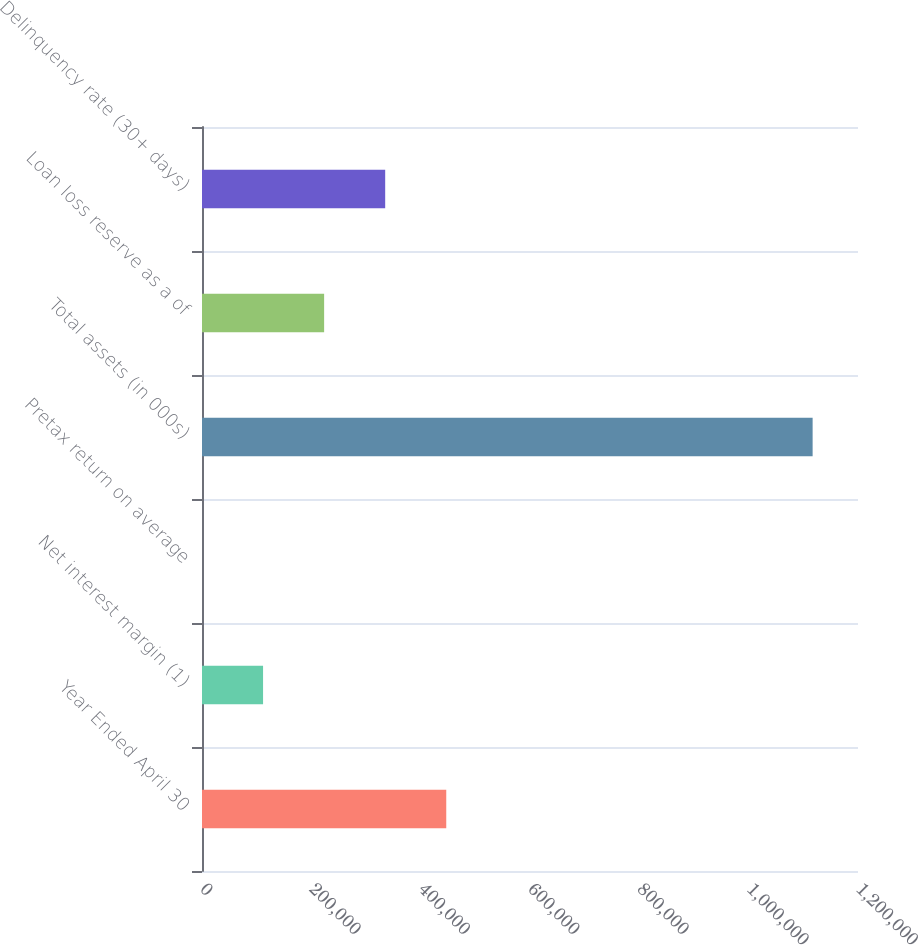Convert chart to OTSL. <chart><loc_0><loc_0><loc_500><loc_500><bar_chart><fcel>Year Ended April 30<fcel>Net interest margin (1)<fcel>Pretax return on average<fcel>Total assets (in 000s)<fcel>Loan loss reserve as a of<fcel>Delinquency rate (30+ days)<nl><fcel>446801<fcel>111701<fcel>1.03<fcel>1.117e+06<fcel>223401<fcel>335101<nl></chart> 